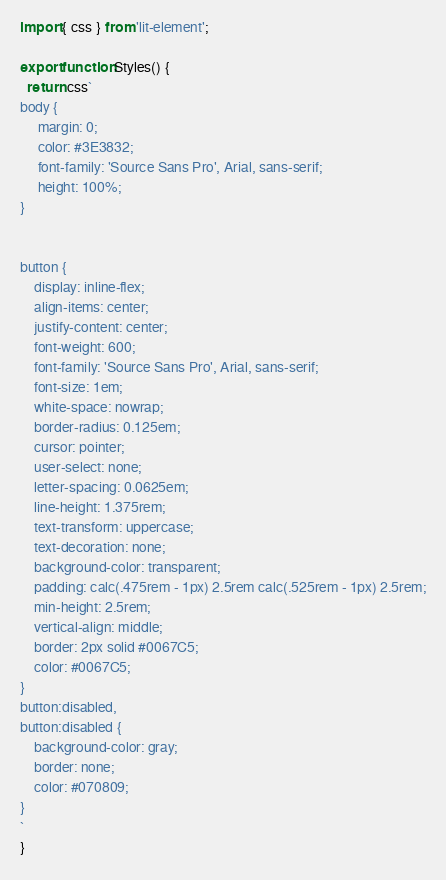Convert code to text. <code><loc_0><loc_0><loc_500><loc_500><_JavaScript_>import { css } from 'lit-element';

export function Styles() {
  return css`
body {
     margin: 0;
     color: #3E3832;
     font-family: 'Source Sans Pro', Arial, sans-serif;
     height: 100%;
}


button {
    display: inline-flex;
    align-items: center;
    justify-content: center;
    font-weight: 600;
    font-family: 'Source Sans Pro', Arial, sans-serif;
    font-size: 1em;
    white-space: nowrap;
    border-radius: 0.125em;
    cursor: pointer;
    user-select: none;
    letter-spacing: 0.0625em;
    line-height: 1.375rem;
    text-transform: uppercase;
    text-decoration: none;
    background-color: transparent;
    padding: calc(.475rem - 1px) 2.5rem calc(.525rem - 1px) 2.5rem;
    min-height: 2.5rem;
    vertical-align: middle;
    border: 2px solid #0067C5;
    color: #0067C5;
}
button:disabled,
button:disabled {
    background-color: gray;
    border: none;
    color: #070809;
}
`
}
</code> 